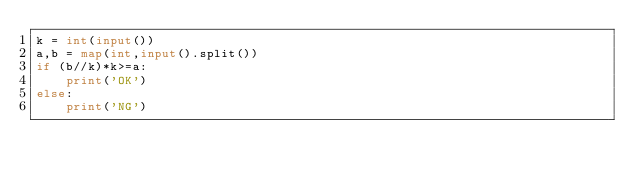<code> <loc_0><loc_0><loc_500><loc_500><_Python_>k = int(input())
a,b = map(int,input().split())
if (b//k)*k>=a:
    print('OK')
else:
    print('NG')</code> 